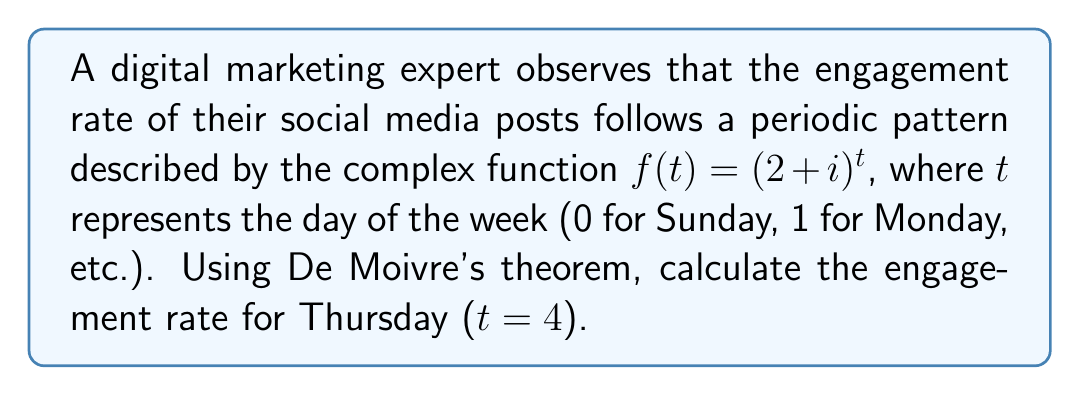Help me with this question. To solve this problem, we'll use De Moivre's theorem and follow these steps:

1) First, we need to express $(2+i)$ in polar form:
   $2+i = r(\cos\theta + i\sin\theta)$
   
   $r = \sqrt{2^2 + 1^2} = \sqrt{5}$
   
   $\theta = \arctan(\frac{1}{2}) \approx 0.4636$ radians

2) Now we can write $(2+i)$ as:
   $2+i = \sqrt{5}(\cos(0.4636) + i\sin(0.4636))$

3) Using De Moivre's theorem, we can express $(2+i)^4$ as:
   $(\sqrt{5})^4(\cos(4 \cdot 0.4636) + i\sin(4 \cdot 0.4636))$

4) Simplify:
   $25(\cos(1.8544) + i\sin(1.8544))$

5) Calculate the real and imaginary parts:
   $25(\cos(1.8544)) \approx -7.2361$
   $25(\sin(1.8544)) \approx 23.7764$

6) Therefore, $(2+i)^4 \approx -7.2361 + 23.7764i$

7) The engagement rate is represented by the magnitude of this complex number:
   $\sqrt{(-7.2361)^2 + (23.7764)^2} \approx 24.8452$
Answer: 24.8452 